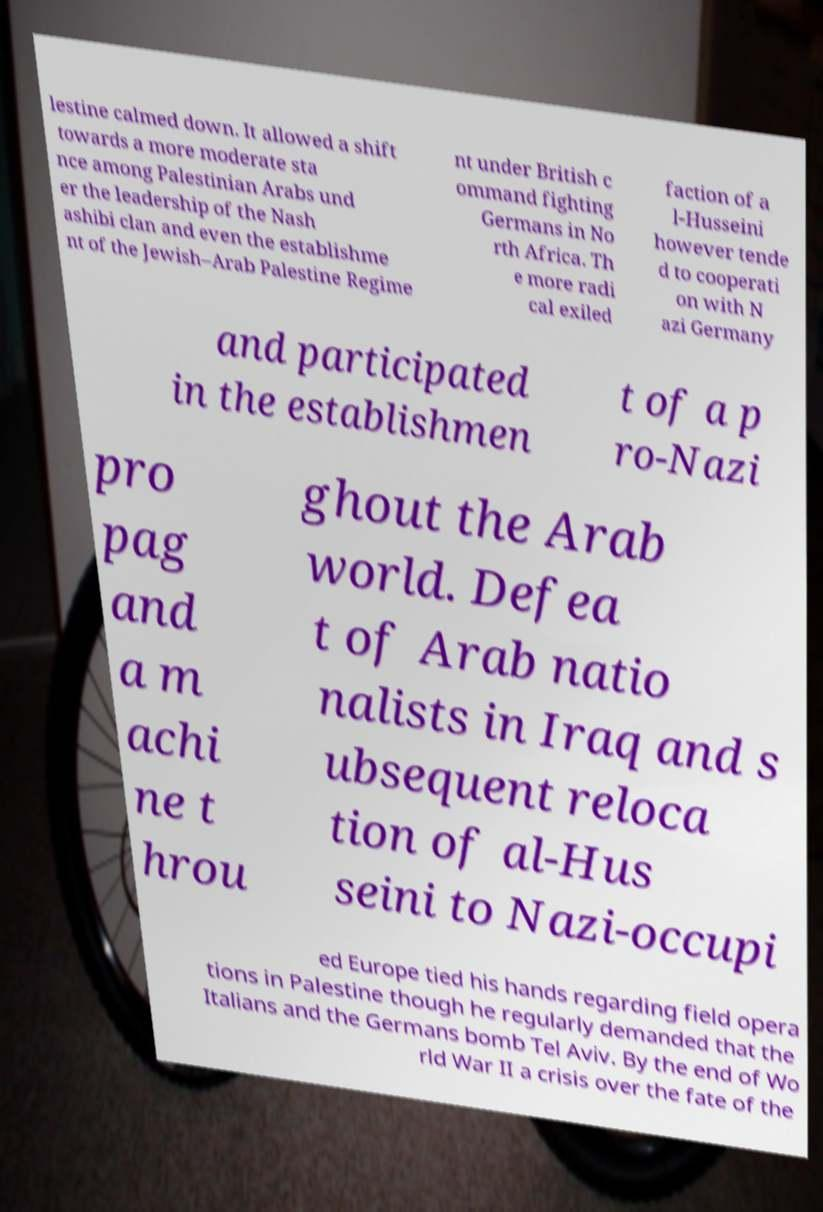There's text embedded in this image that I need extracted. Can you transcribe it verbatim? lestine calmed down. It allowed a shift towards a more moderate sta nce among Palestinian Arabs und er the leadership of the Nash ashibi clan and even the establishme nt of the Jewish–Arab Palestine Regime nt under British c ommand fighting Germans in No rth Africa. Th e more radi cal exiled faction of a l-Husseini however tende d to cooperati on with N azi Germany and participated in the establishmen t of a p ro-Nazi pro pag and a m achi ne t hrou ghout the Arab world. Defea t of Arab natio nalists in Iraq and s ubsequent reloca tion of al-Hus seini to Nazi-occupi ed Europe tied his hands regarding field opera tions in Palestine though he regularly demanded that the Italians and the Germans bomb Tel Aviv. By the end of Wo rld War II a crisis over the fate of the 